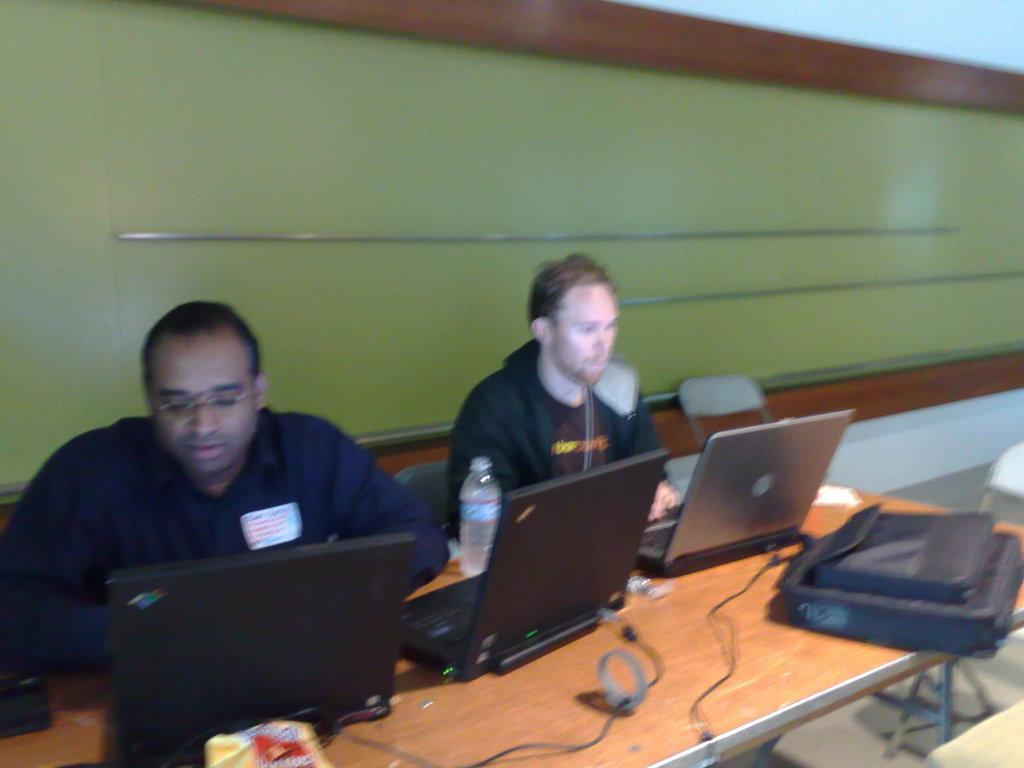Can you describe this image briefly? In this image there are two people sitting in chairs and are using laptops in front of them on the table. On the table there are cables and a bag, beside them there are empty chairs. Behind them there is a wall. 